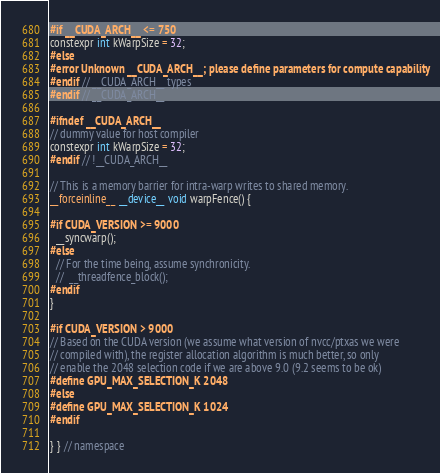Convert code to text. <code><loc_0><loc_0><loc_500><loc_500><_Cuda_>#if __CUDA_ARCH__ <= 750
constexpr int kWarpSize = 32;
#else
#error Unknown __CUDA_ARCH__; please define parameters for compute capability
#endif // __CUDA_ARCH__ types
#endif // __CUDA_ARCH__

#ifndef __CUDA_ARCH__
// dummy value for host compiler
constexpr int kWarpSize = 32;
#endif // !__CUDA_ARCH__

// This is a memory barrier for intra-warp writes to shared memory.
__forceinline__ __device__ void warpFence() {

#if CUDA_VERSION >= 9000
  __syncwarp();
#else
  // For the time being, assume synchronicity.
  //  __threadfence_block();
#endif
}

#if CUDA_VERSION > 9000
// Based on the CUDA version (we assume what version of nvcc/ptxas we were
// compiled with), the register allocation algorithm is much better, so only
// enable the 2048 selection code if we are above 9.0 (9.2 seems to be ok)
#define GPU_MAX_SELECTION_K 2048
#else
#define GPU_MAX_SELECTION_K 1024
#endif

} } // namespace
</code> 